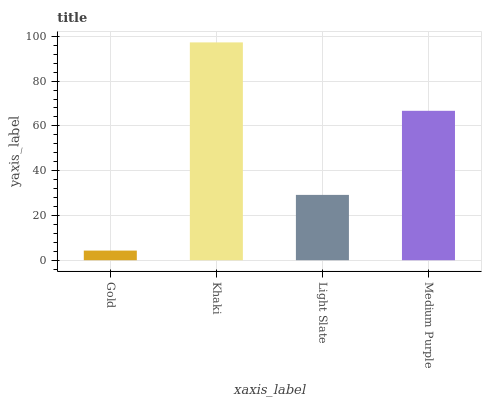Is Gold the minimum?
Answer yes or no. Yes. Is Khaki the maximum?
Answer yes or no. Yes. Is Light Slate the minimum?
Answer yes or no. No. Is Light Slate the maximum?
Answer yes or no. No. Is Khaki greater than Light Slate?
Answer yes or no. Yes. Is Light Slate less than Khaki?
Answer yes or no. Yes. Is Light Slate greater than Khaki?
Answer yes or no. No. Is Khaki less than Light Slate?
Answer yes or no. No. Is Medium Purple the high median?
Answer yes or no. Yes. Is Light Slate the low median?
Answer yes or no. Yes. Is Khaki the high median?
Answer yes or no. No. Is Medium Purple the low median?
Answer yes or no. No. 